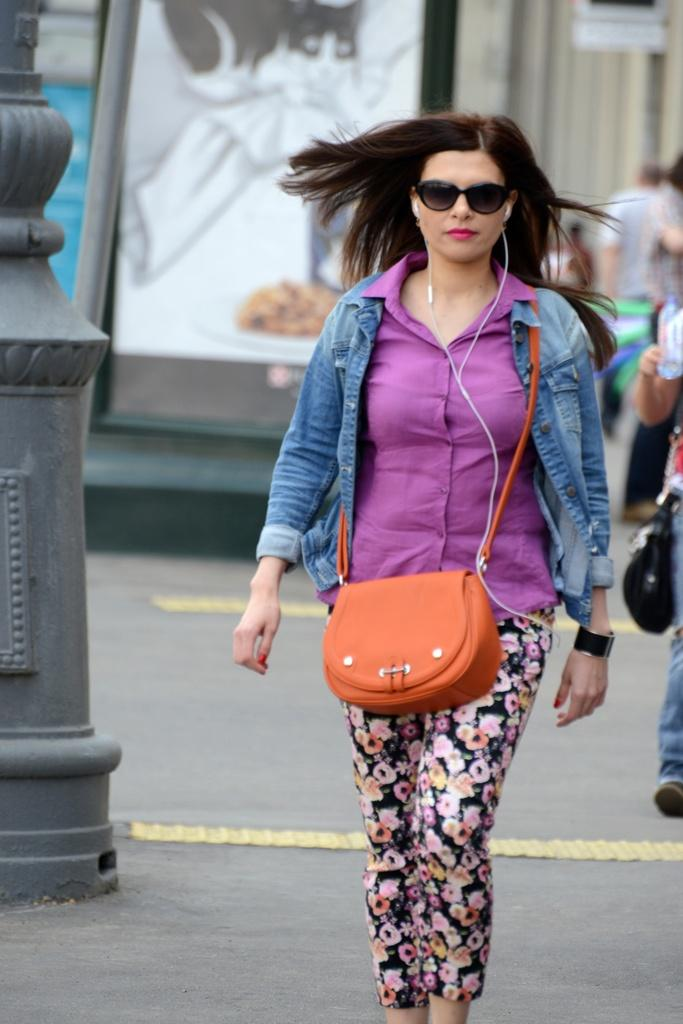What is the main subject of the picture? The main subject of the picture is a woman. How is the woman being highlighted in the image? The woman is highlighted, but the specific method is not mentioned in the facts. What type of clothing is the woman wearing? The woman is wearing a jacket. What is the woman carrying in the image? The woman is carrying a bag. What protective gear is the woman wearing? The woman is wearing goggles. What accessory is the woman wearing on her wrist? The woman is wearing a watch. Are there any other people in the image? Yes, there are other persons standing in the image. What is on the wall in the image? There is a picture on the wall. What architectural feature can be seen in the image? There is a pole in the image. What is the temperature of the burn on the woman's hand in the image? There is no mention of a burn on the woman's hand in the image, so we cannot determine the temperature. What school does the woman attend in the image? There is no information about the woman attending school in the image, so we cannot determine which school she might attend. 